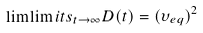Convert formula to latex. <formula><loc_0><loc_0><loc_500><loc_500>\lim \lim i t s _ { t \rightarrow \infty } D ( t ) = ( \upsilon _ { e q } ) ^ { 2 }</formula> 